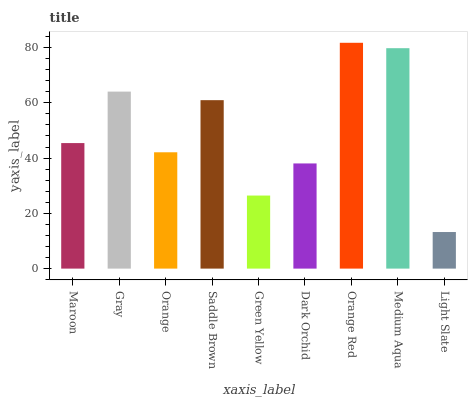Is Light Slate the minimum?
Answer yes or no. Yes. Is Orange Red the maximum?
Answer yes or no. Yes. Is Gray the minimum?
Answer yes or no. No. Is Gray the maximum?
Answer yes or no. No. Is Gray greater than Maroon?
Answer yes or no. Yes. Is Maroon less than Gray?
Answer yes or no. Yes. Is Maroon greater than Gray?
Answer yes or no. No. Is Gray less than Maroon?
Answer yes or no. No. Is Maroon the high median?
Answer yes or no. Yes. Is Maroon the low median?
Answer yes or no. Yes. Is Gray the high median?
Answer yes or no. No. Is Light Slate the low median?
Answer yes or no. No. 